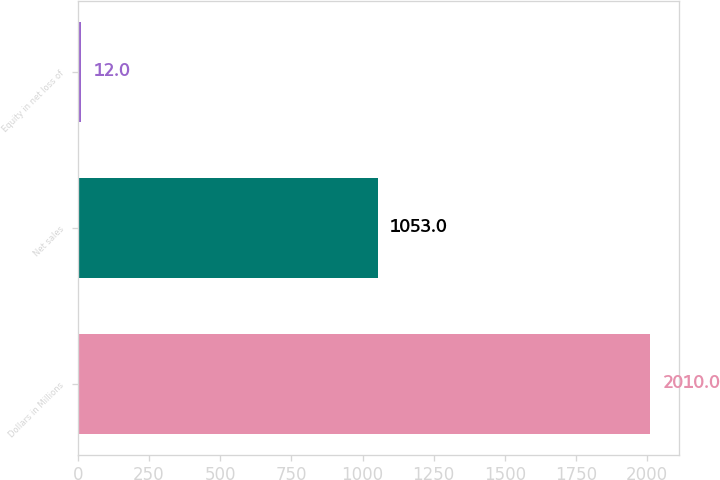<chart> <loc_0><loc_0><loc_500><loc_500><bar_chart><fcel>Dollars in Millions<fcel>Net sales<fcel>Equity in net loss of<nl><fcel>2010<fcel>1053<fcel>12<nl></chart> 